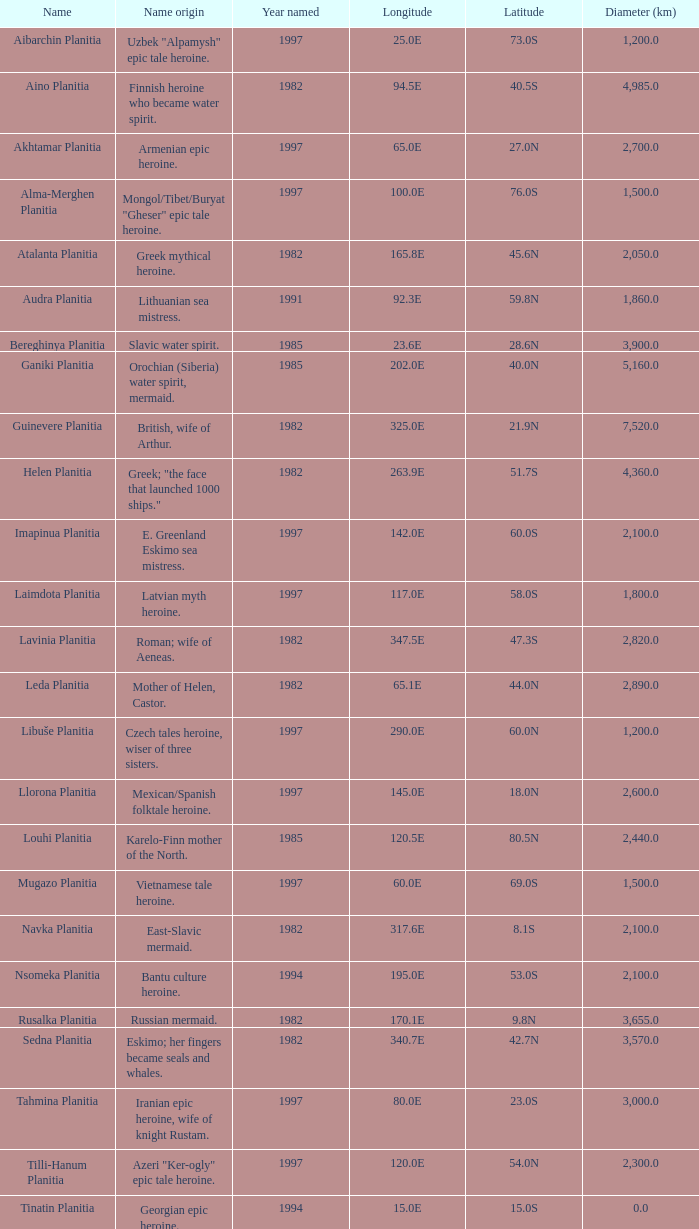What is the diameter (km) of the feature of latitude 23.0s 3000.0. 